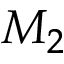<formula> <loc_0><loc_0><loc_500><loc_500>M _ { 2 }</formula> 